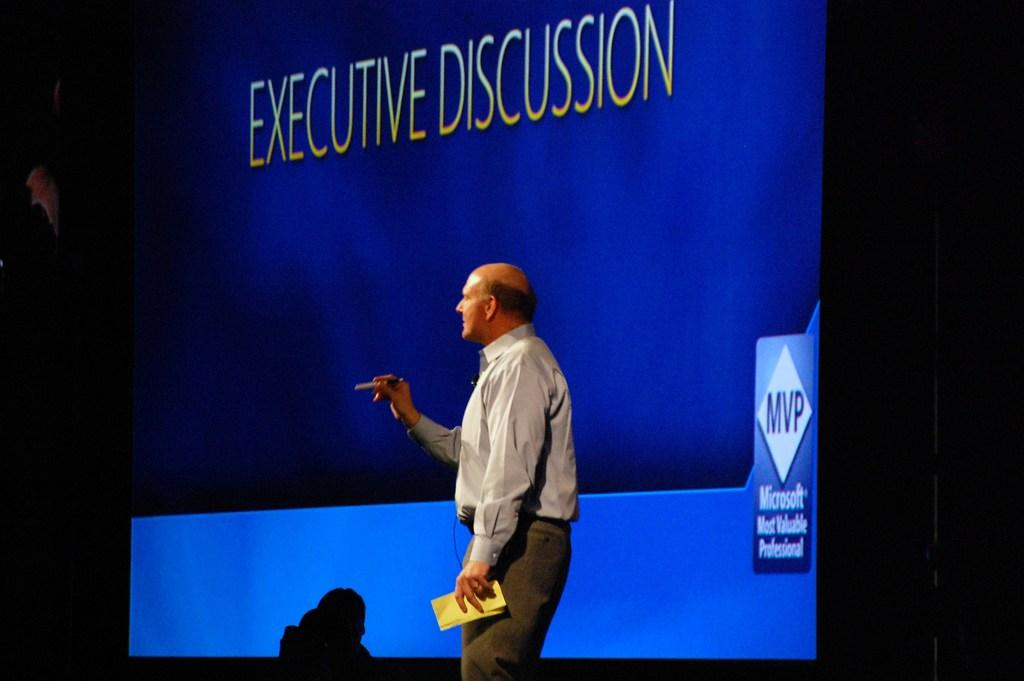What is the main subject of the image? There is a man in the image. What is the man doing in the image? The man is standing in the image. What is the man holding in his hand? The man is holding a pen and a paper in the image. What can be seen in the background of the image? There is a screen in the background of the image, and text is visible on the screen. Can you tell me how many thumbs the man has on his left hand in the image? The image does not show the man's thumbs, so it is not possible to determine the number of thumbs on his left hand. What type of animals can be seen at the zoo in the image? There is no zoo or animals present in the image; it features a man standing with a pen and a paper. 